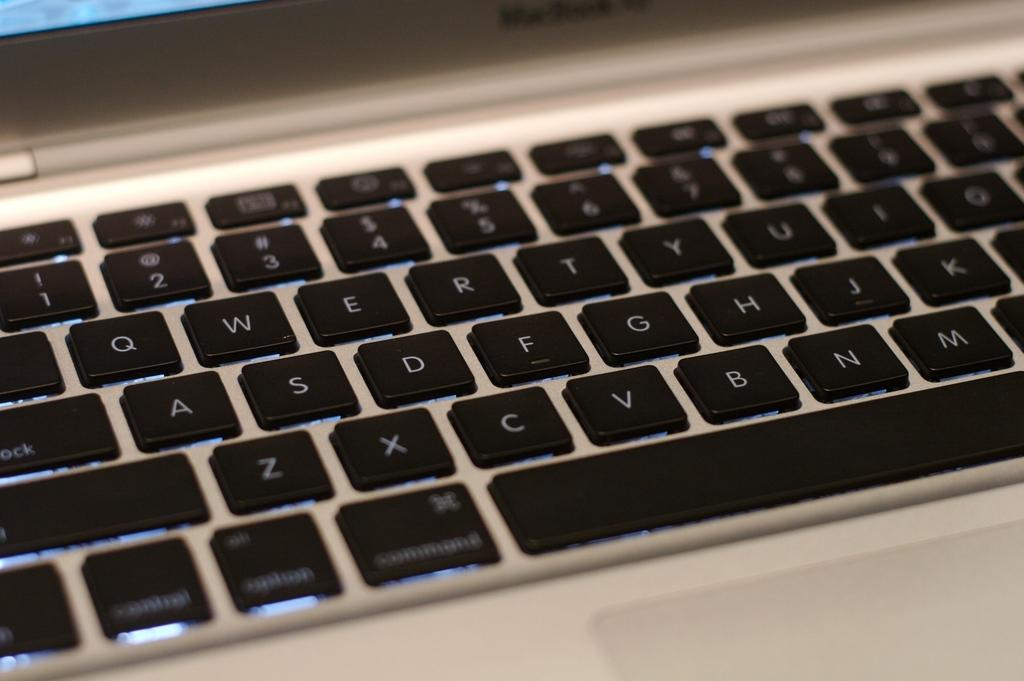Provide a one-sentence caption for the provided image. A computer keyboard displaying the letters of the alphabet including A, S, D, F, and G. 